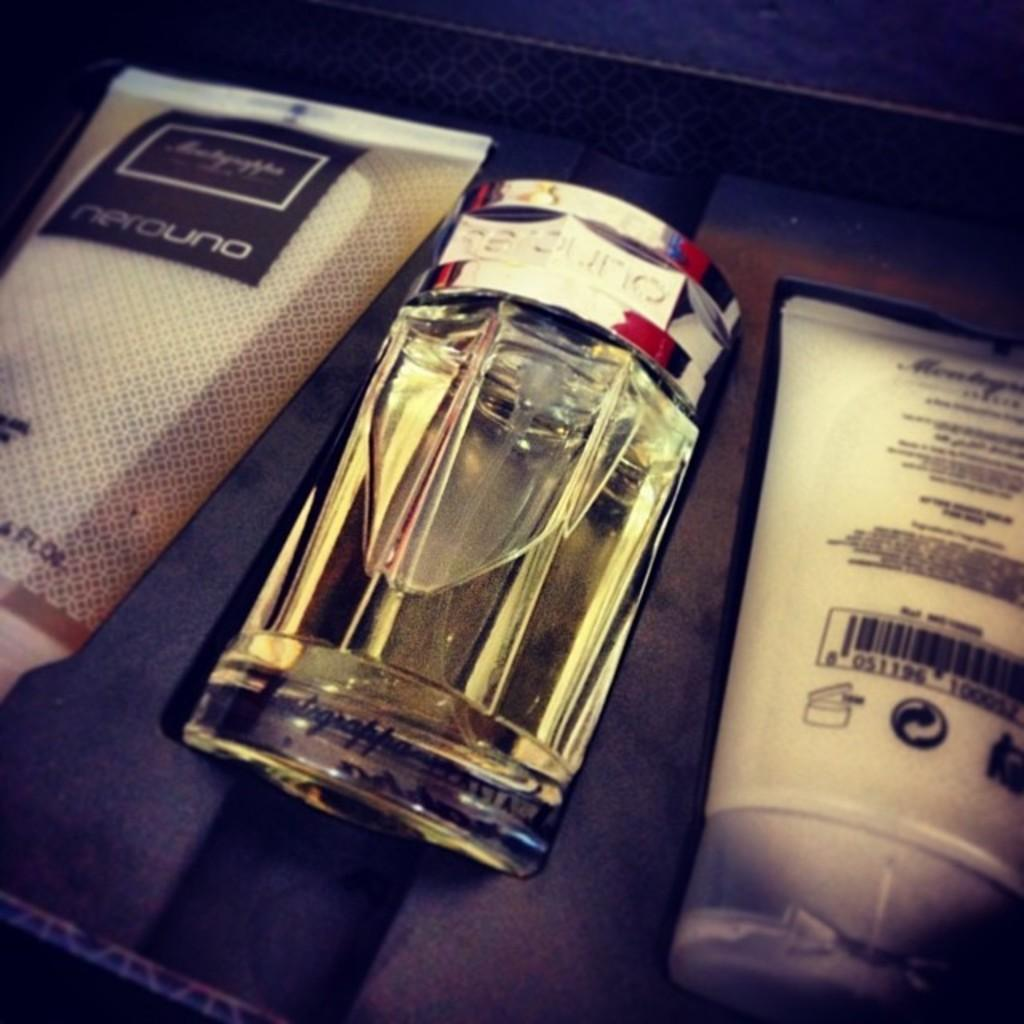<image>
Give a short and clear explanation of the subsequent image. The cologne and lotion gift set is NeroUno brand. 